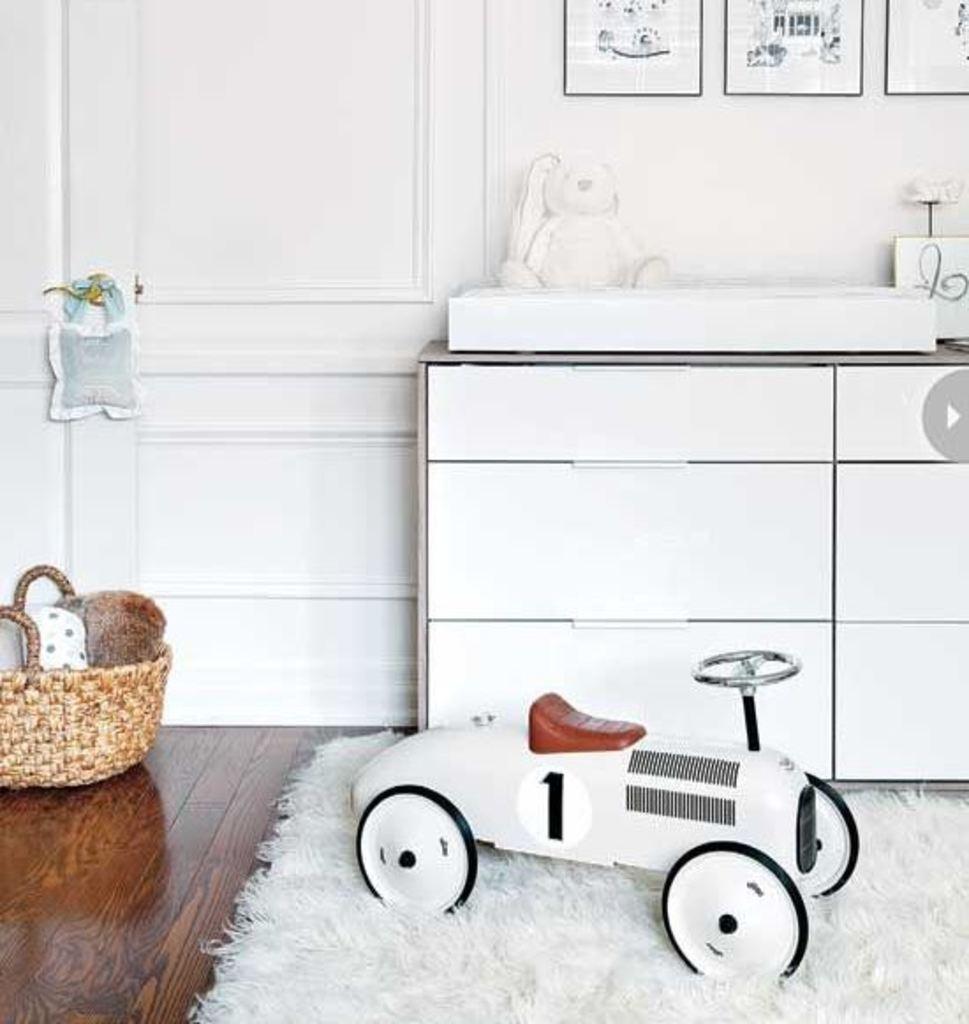Describe this image in one or two sentences. In this image in the front there is mat on the floor and on the mat there is a toy vehicle. On the left side there is a basket on the floor. In the background there is a wall and on the wall there are frames and in front of the wall there is a table, on a table there is a toy and there are objects which are white in colour and there is a door on the left side of the table and on the handle of the door there is an object hanging which is white in colour. 